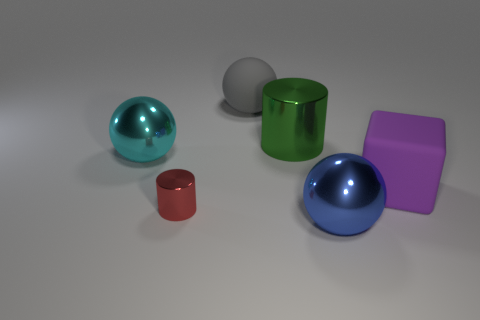What texture do the objects in the image appear to have? The objects seem to have a smooth and shiny texture, suggesting they might feel sleek to the touch, likely reflecting their rigid and glossy surface qualities. 